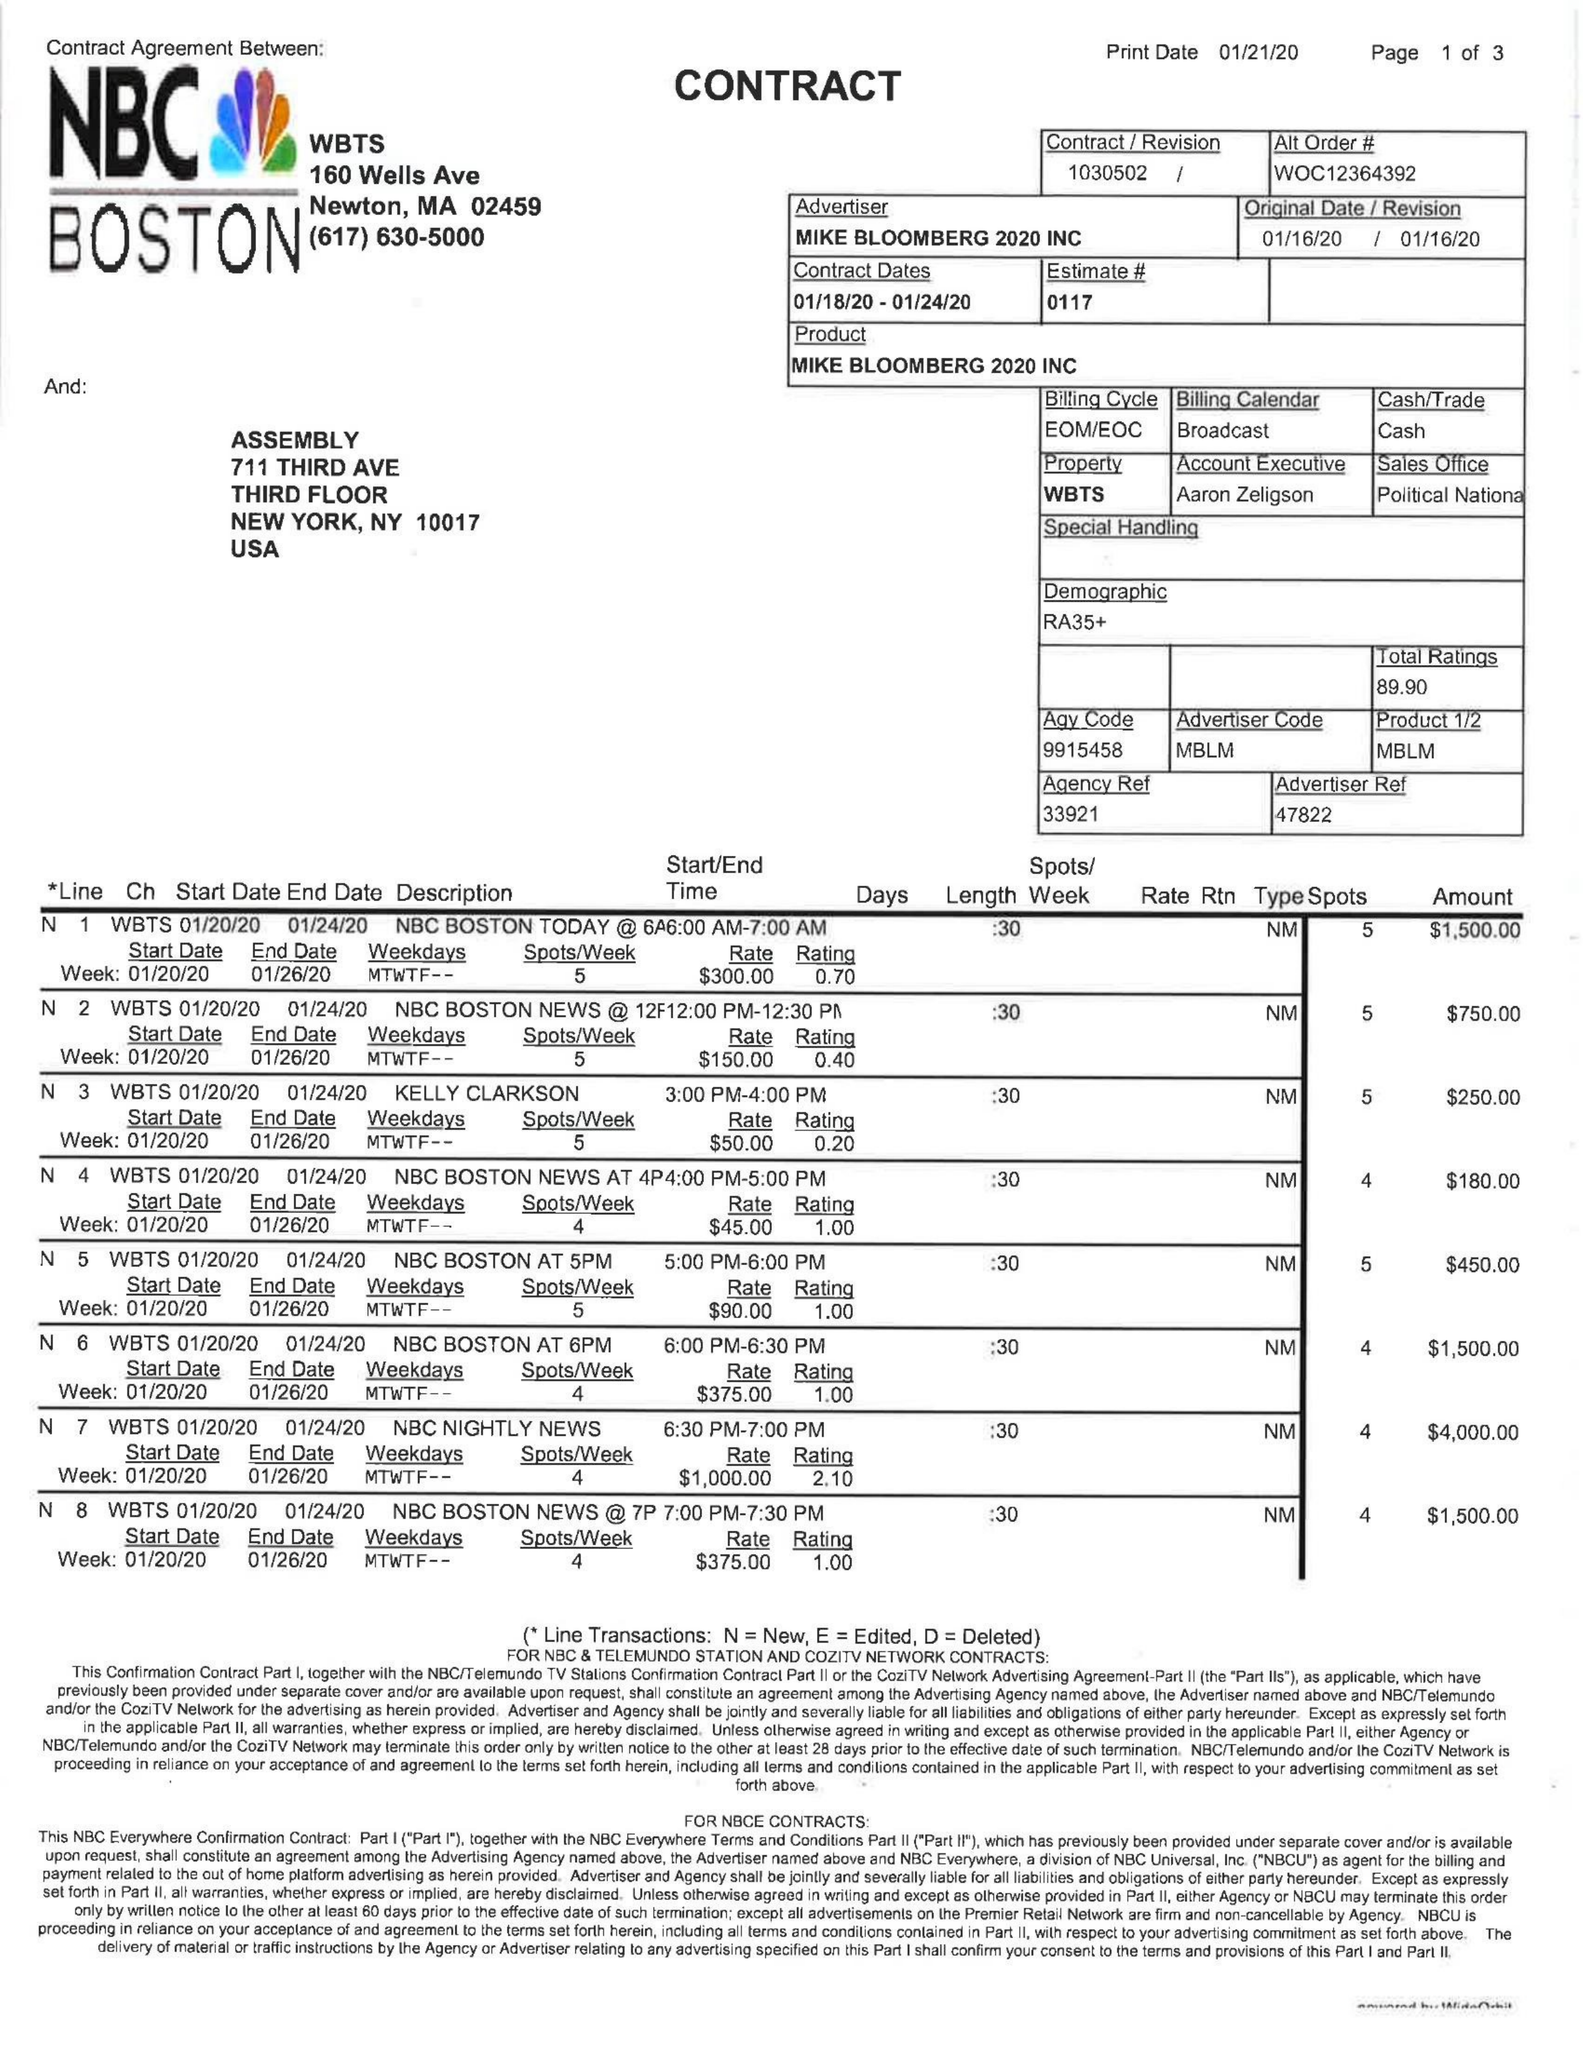What is the value for the gross_amount?
Answer the question using a single word or phrase. 60150.00 